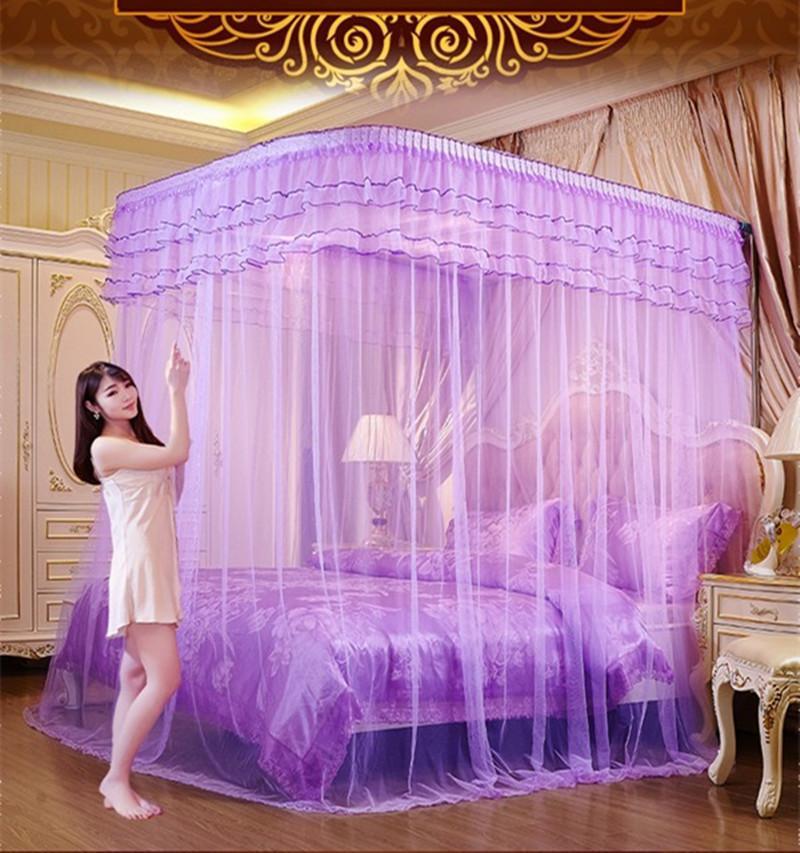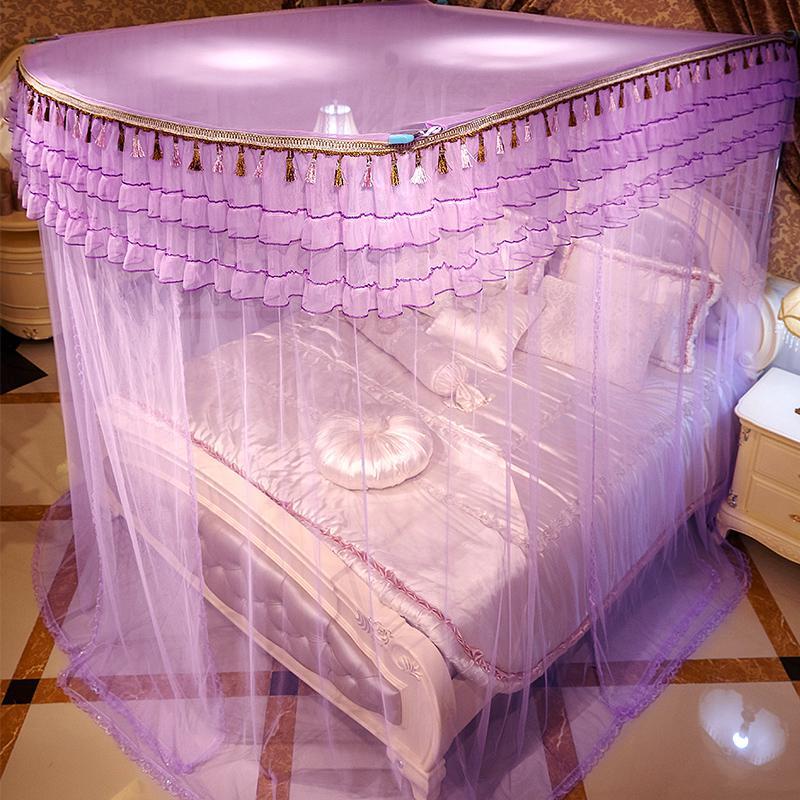The first image is the image on the left, the second image is the image on the right. Given the left and right images, does the statement "The bed set in the left image has a pink canopy above it." hold true? Answer yes or no. No. 